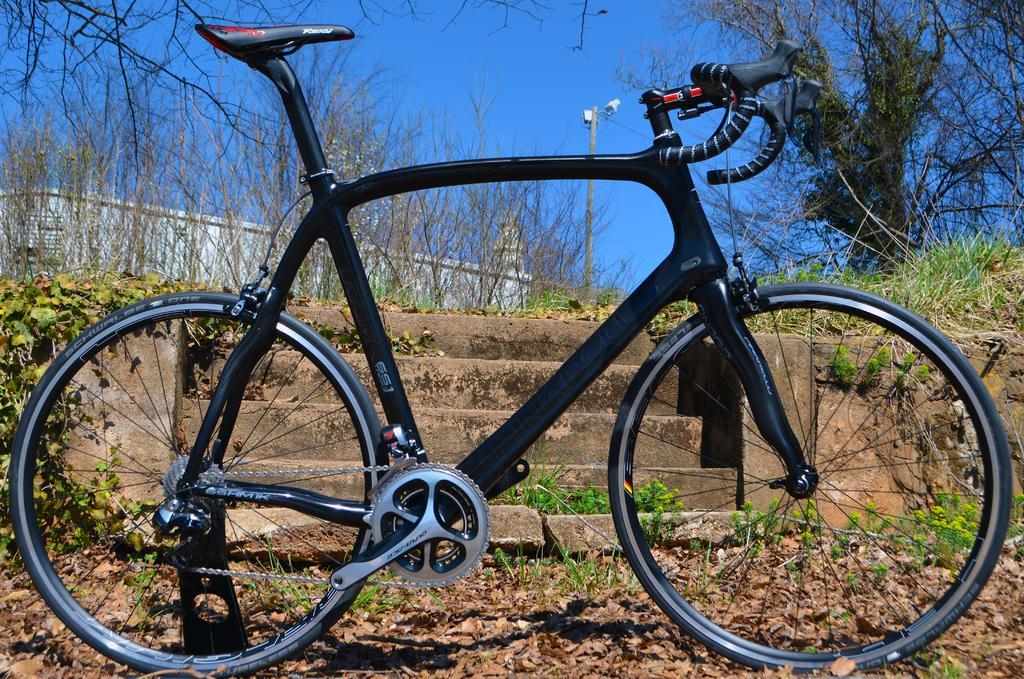Can you describe this image briefly? In the image in the center we can see one bicycle,which is in black color. In the background we can see the sky,trees,plants,grass,dry leaves,pole,staircase and fence. 